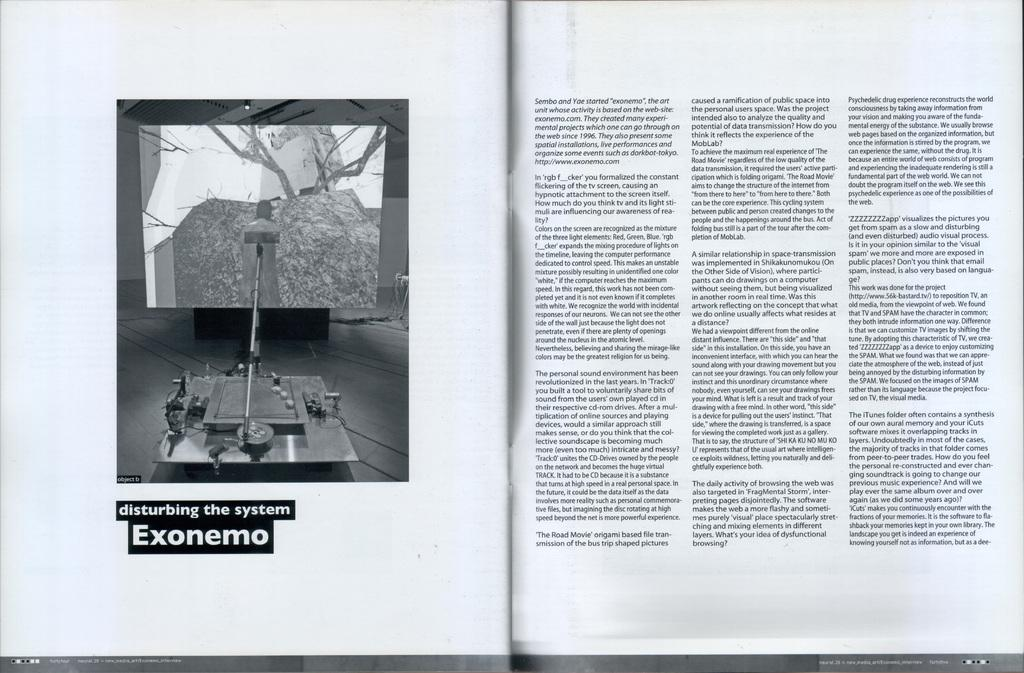<image>
Share a concise interpretation of the image provided. An open book that shows a machine and reads disturbing the system Exonemo. 